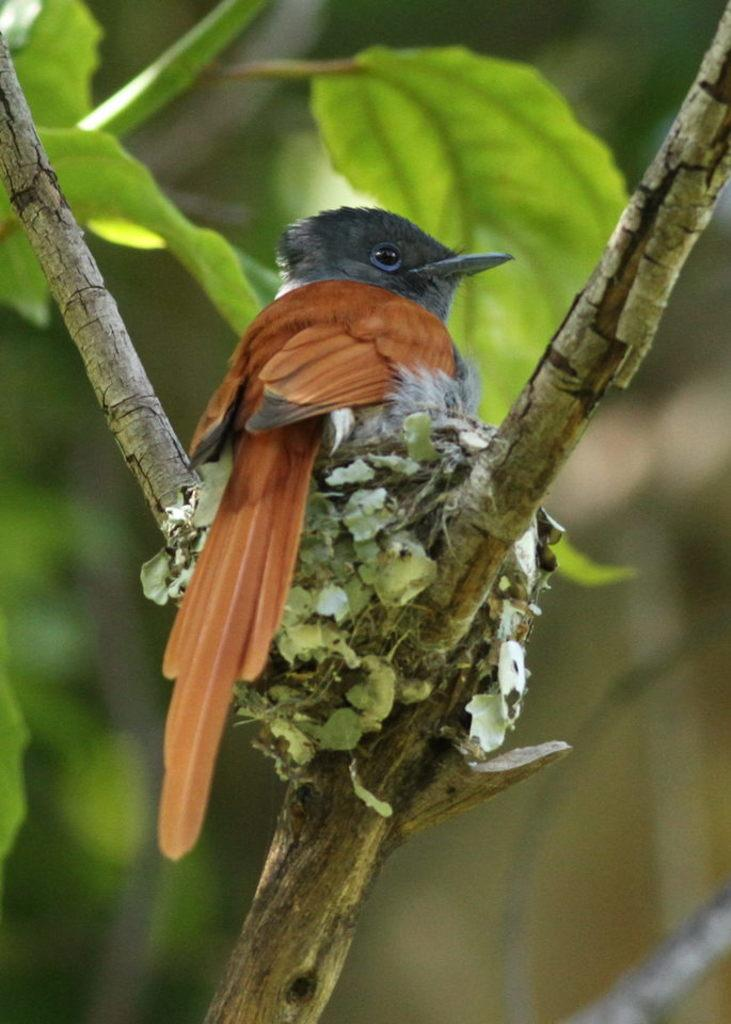What is located on a branch of a tree in the image? There is a nest on a branch of a tree in the image. What can be seen inside the nest? There is a bird on the nest in the image. What type of vegetation is visible in the background of the image? Leaves are visible in the background of the image. How would you describe the clarity of the background in the image? The background is blurry in the image. What type of beef is being cooked in the image? There is no beef present in the image; it features a nest with a bird on a tree branch, surrounded by leaves and a blurry background. 